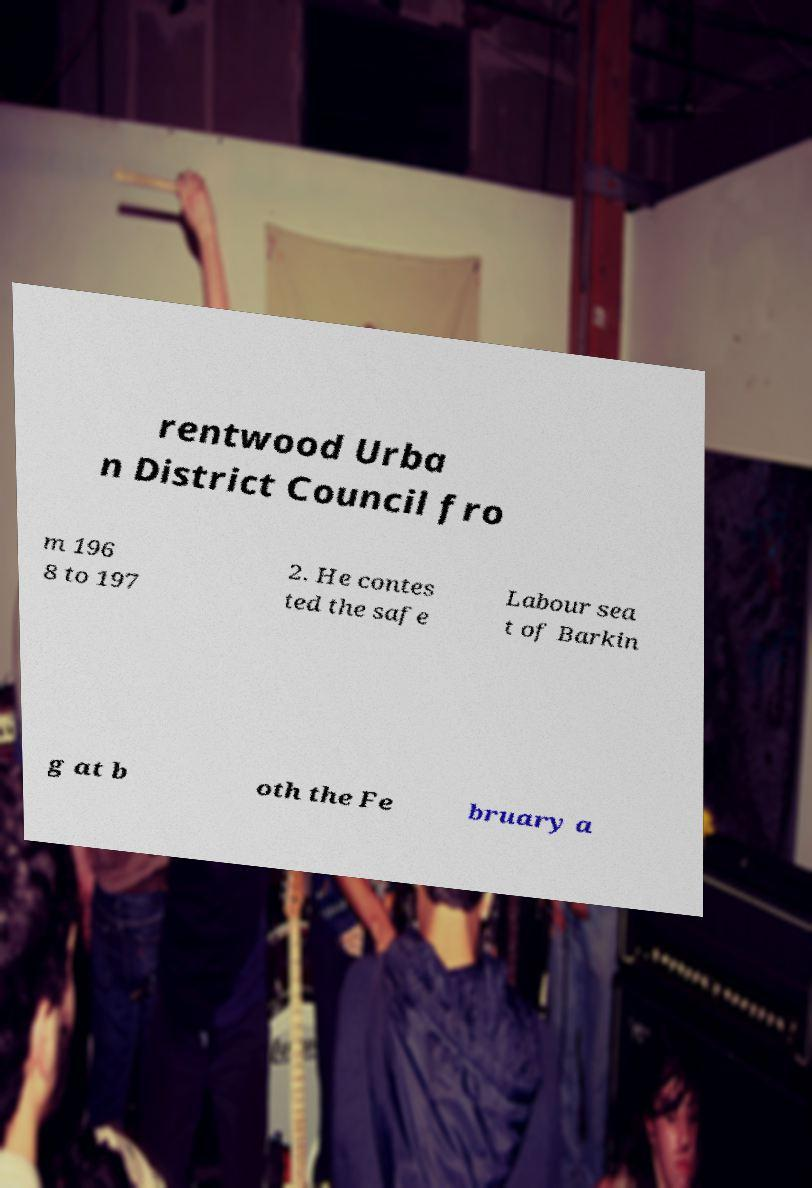There's text embedded in this image that I need extracted. Can you transcribe it verbatim? rentwood Urba n District Council fro m 196 8 to 197 2. He contes ted the safe Labour sea t of Barkin g at b oth the Fe bruary a 